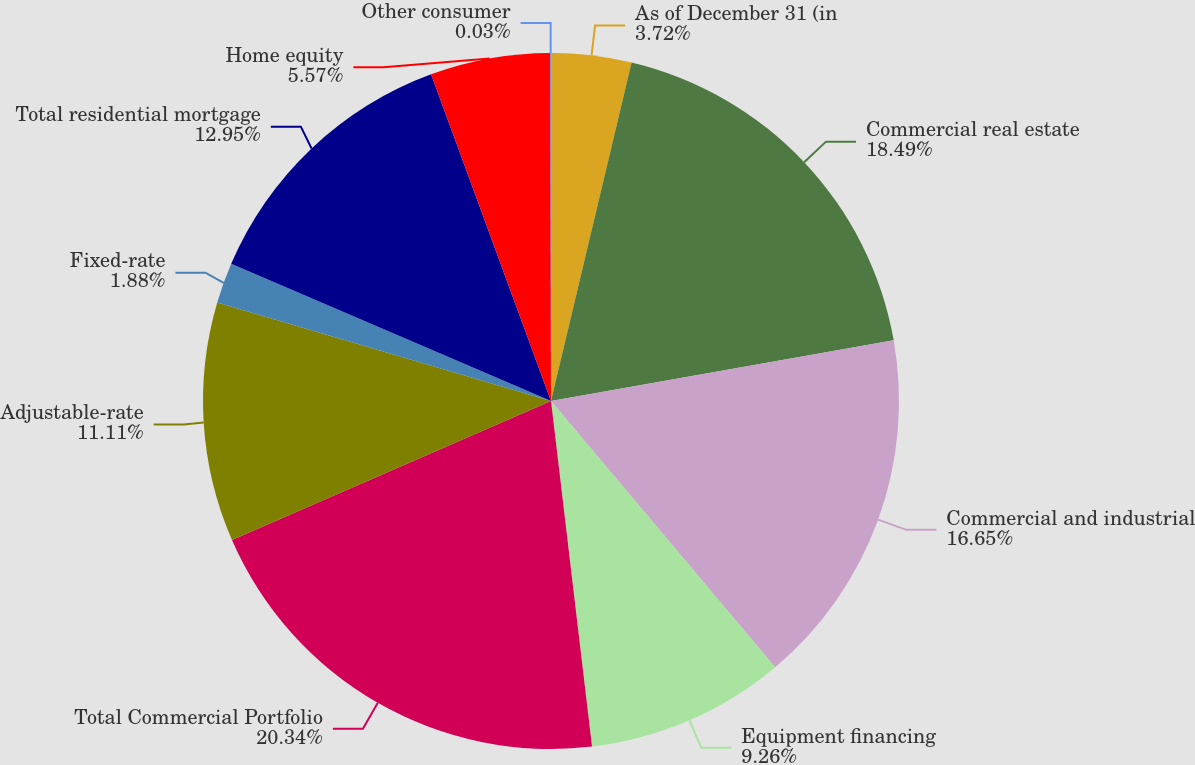<chart> <loc_0><loc_0><loc_500><loc_500><pie_chart><fcel>As of December 31 (in<fcel>Commercial real estate<fcel>Commercial and industrial<fcel>Equipment financing<fcel>Total Commercial Portfolio<fcel>Adjustable-rate<fcel>Fixed-rate<fcel>Total residential mortgage<fcel>Home equity<fcel>Other consumer<nl><fcel>3.72%<fcel>18.49%<fcel>16.65%<fcel>9.26%<fcel>20.34%<fcel>11.11%<fcel>1.88%<fcel>12.95%<fcel>5.57%<fcel>0.03%<nl></chart> 